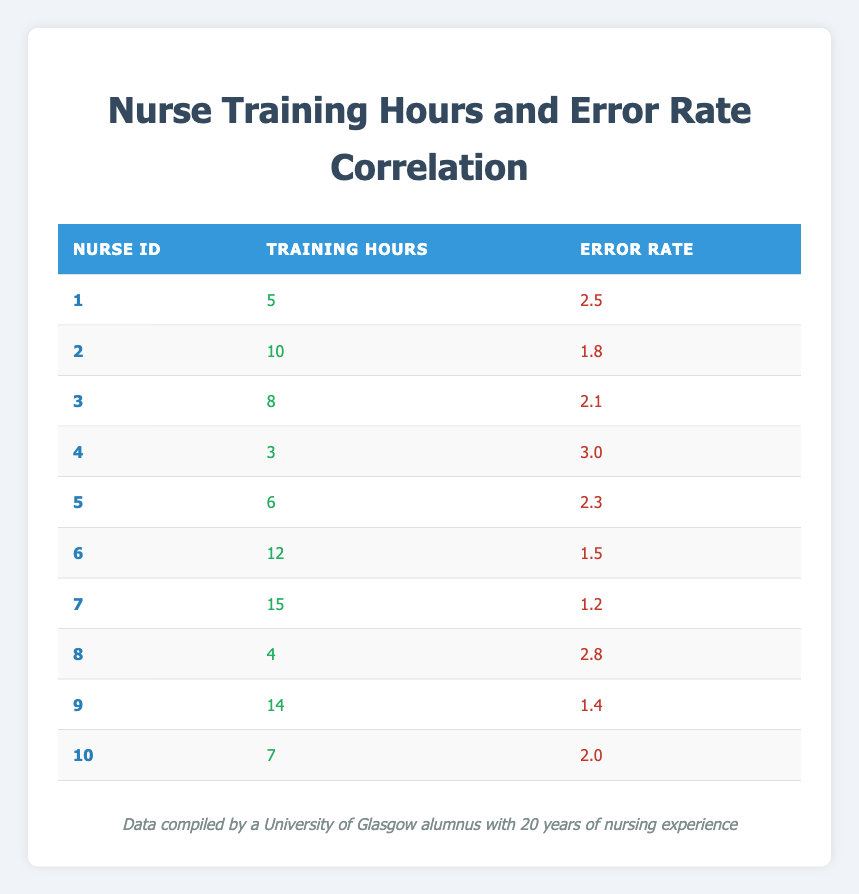What is the error rate for Nurse ID 3? Looking at the table, Nurse ID 3 has an error rate listed under the "Error Rate" column, which is 2.1.
Answer: 2.1 What is the training hours for Nurse ID 7? In the table, the "Training Hours" column for Nurse ID 7 shows a value of 15.
Answer: 15 Which nurse has the highest error rate? By comparing the "Error Rate" values in the table, Nurse ID 4 has the highest error rate of 3.0.
Answer: Nurse ID 4 What is the average error rate for nurses who received more than 10 training hours? The nurses with more than 10 training hours are Nurse ID 6 (1.5), Nurse ID 7 (1.2), and Nurse ID 9 (1.4). The average is calculated as (1.5 + 1.2 + 1.4) / 3 = 4.1 / 3 which equals approximately 1.37.
Answer: 1.37 Do any nurses with less than 5 training hours have an error rate of 3 or higher? In the table, Nurse ID 4 with 3 training hours has an error rate of 3.0, which confirms that there is a nurse satisfying both conditions.
Answer: Yes What is the difference in error rates between the nurse with the most training hours and the one with the least? Nurse ID 7 has the most training hours (15) with an error rate of 1.2, and Nurse ID 4 has the least training hours (3) with an error rate of 3.0. The difference is calculated as 3.0 - 1.2 = 1.8.
Answer: 1.8 What is the total number of training hours for all nurses? The total training hours can be calculated by adding up all the values in the "Training Hours" column: 5 + 10 + 8 + 3 + 6 + 12 + 15 + 4 + 14 + 7 = 84.
Answer: 84 Is there any nurse with exactly 6 training hours who has an error rate below 2.0? Checking the table, Nurse ID 5 has 6 training hours and an error rate of 2.3, which is above 2.0. Therefore, no nurse meets the criteria.
Answer: No 